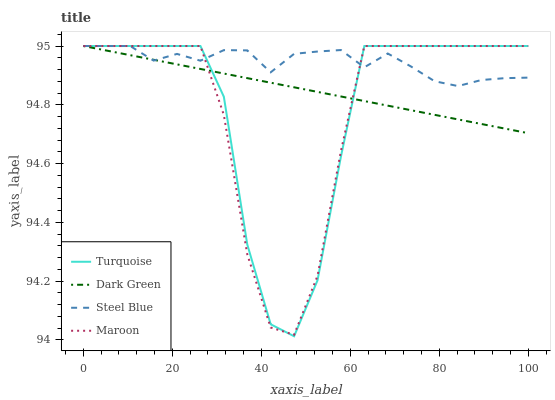Does Maroon have the minimum area under the curve?
Answer yes or no. Yes. Does Steel Blue have the maximum area under the curve?
Answer yes or no. Yes. Does Steel Blue have the minimum area under the curve?
Answer yes or no. No. Does Maroon have the maximum area under the curve?
Answer yes or no. No. Is Dark Green the smoothest?
Answer yes or no. Yes. Is Turquoise the roughest?
Answer yes or no. Yes. Is Steel Blue the smoothest?
Answer yes or no. No. Is Steel Blue the roughest?
Answer yes or no. No. Does Turquoise have the lowest value?
Answer yes or no. Yes. Does Maroon have the lowest value?
Answer yes or no. No. Does Dark Green have the highest value?
Answer yes or no. Yes. Does Turquoise intersect Dark Green?
Answer yes or no. Yes. Is Turquoise less than Dark Green?
Answer yes or no. No. Is Turquoise greater than Dark Green?
Answer yes or no. No. 